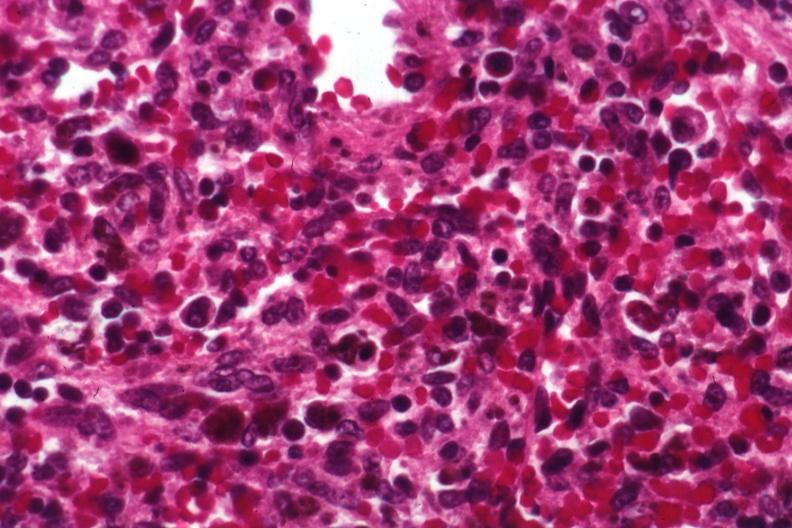s spleen present?
Answer the question using a single word or phrase. Yes 